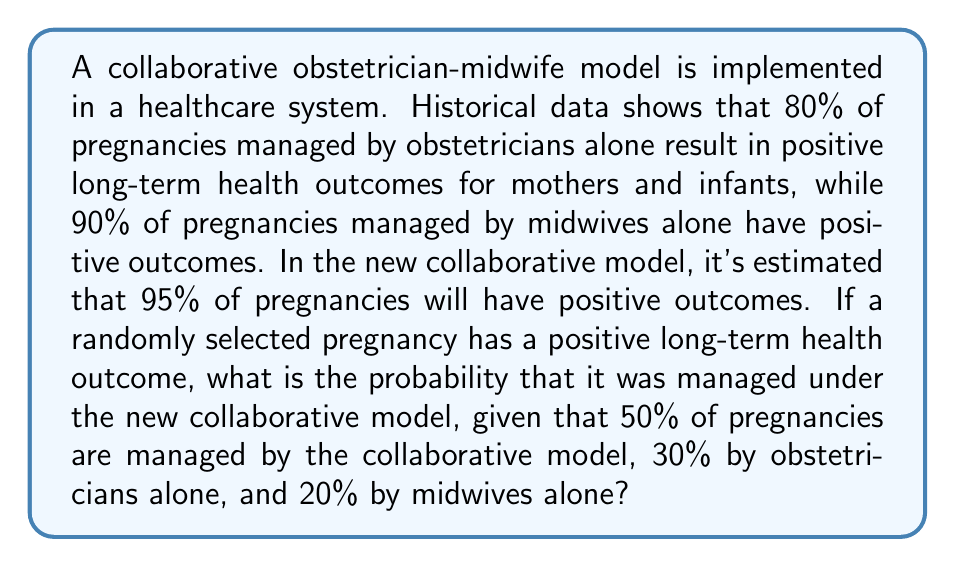Teach me how to tackle this problem. Let's approach this problem using Bayesian inference:

1. Define events:
   A: Positive long-term health outcome
   C: Collaborative model
   O: Obstetrician alone
   M: Midwife alone

2. Given probabilities:
   P(C) = 0.50, P(O) = 0.30, P(M) = 0.20
   P(A|C) = 0.95, P(A|O) = 0.80, P(A|M) = 0.90

3. Calculate P(A) using the law of total probability:
   P(A) = P(A|C)P(C) + P(A|O)P(O) + P(A|M)P(M)
   P(A) = 0.95 * 0.50 + 0.80 * 0.30 + 0.90 * 0.20
   P(A) = 0.475 + 0.24 + 0.18 = 0.895

4. Apply Bayes' theorem to find P(C|A):
   $$P(C|A) = \frac{P(A|C)P(C)}{P(A)}$$

5. Substitute the values:
   $$P(C|A) = \frac{0.95 * 0.50}{0.895} = \frac{0.475}{0.895} \approx 0.5307$$

Therefore, the probability that a pregnancy with a positive long-term health outcome was managed under the new collaborative model is approximately 0.5307 or 53.07%.
Answer: 0.5307 